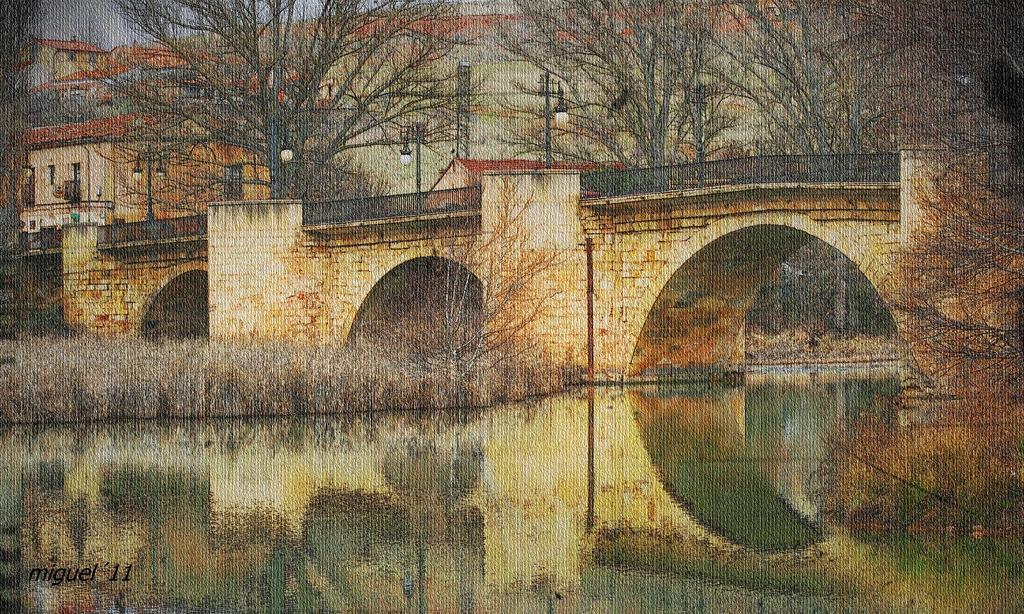Can you describe this image briefly? In this image there is painting. There is a bridge having few street lights on it. Behind there are few trees and buildings. Bottom of image there is water. Beside there is some grass. 